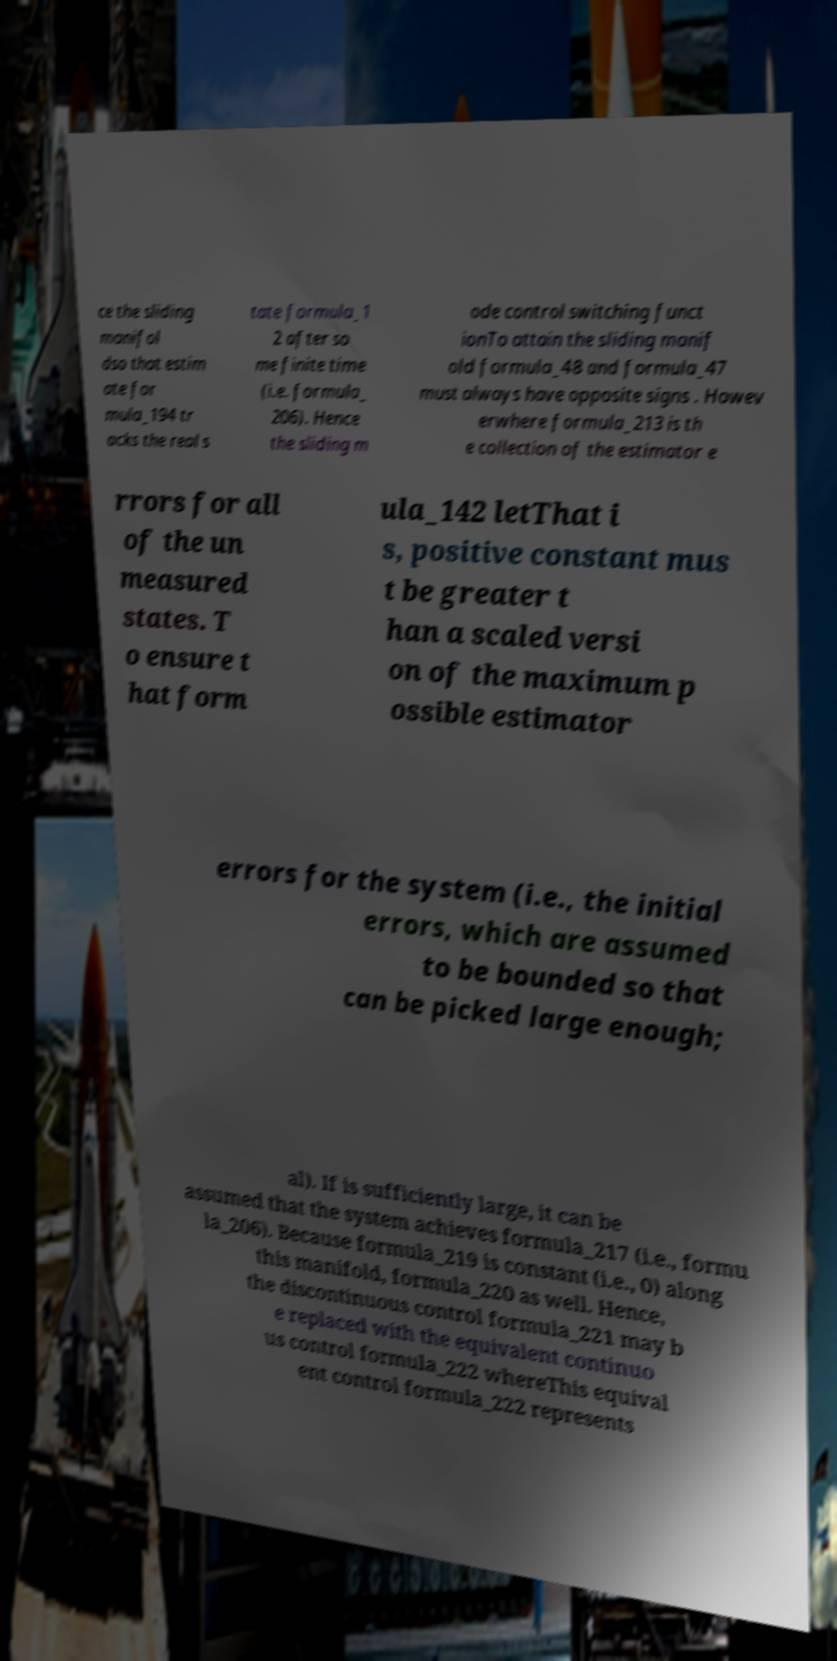What messages or text are displayed in this image? I need them in a readable, typed format. ce the sliding manifol dso that estim ate for mula_194 tr acks the real s tate formula_1 2 after so me finite time (i.e. formula_ 206). Hence the sliding m ode control switching funct ionTo attain the sliding manif old formula_48 and formula_47 must always have opposite signs . Howev erwhere formula_213 is th e collection of the estimator e rrors for all of the un measured states. T o ensure t hat form ula_142 letThat i s, positive constant mus t be greater t han a scaled versi on of the maximum p ossible estimator errors for the system (i.e., the initial errors, which are assumed to be bounded so that can be picked large enough; al). If is sufficiently large, it can be assumed that the system achieves formula_217 (i.e., formu la_206). Because formula_219 is constant (i.e., 0) along this manifold, formula_220 as well. Hence, the discontinuous control formula_221 may b e replaced with the equivalent continuo us control formula_222 whereThis equival ent control formula_222 represents 